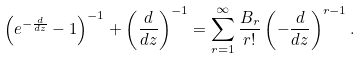<formula> <loc_0><loc_0><loc_500><loc_500>\left ( e ^ { - \frac { d } { d z } } - 1 \right ) ^ { - 1 } + \left ( \frac { d } { d z } \right ) ^ { - 1 } = \sum _ { r = 1 } ^ { \infty } \frac { B _ { r } } { r ! } \left ( - \frac { d } { d z } \right ) ^ { r - 1 } .</formula> 